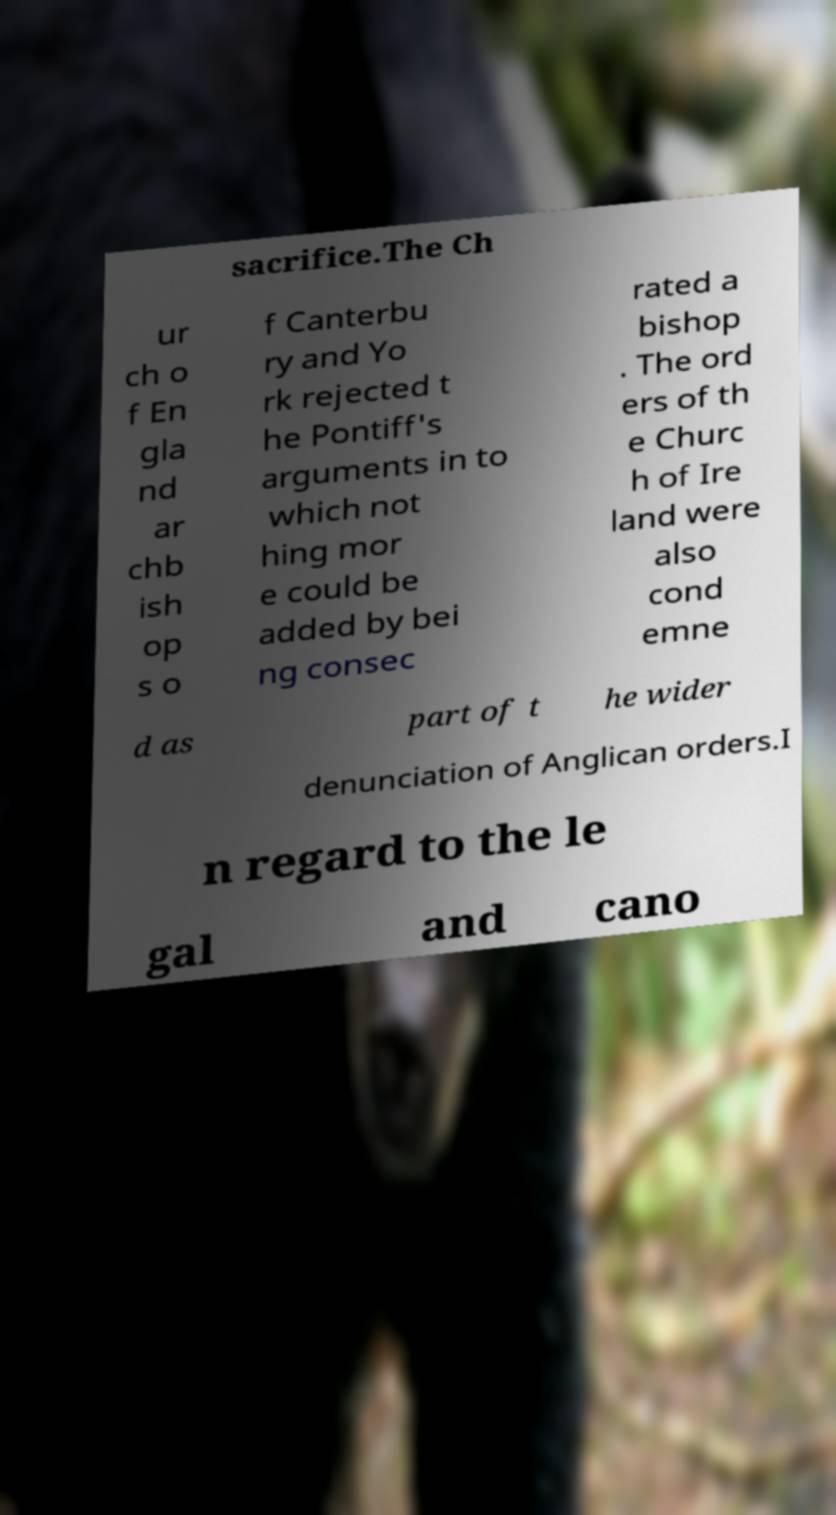Please identify and transcribe the text found in this image. sacrifice.The Ch ur ch o f En gla nd ar chb ish op s o f Canterbu ry and Yo rk rejected t he Pontiff's arguments in to which not hing mor e could be added by bei ng consec rated a bishop . The ord ers of th e Churc h of Ire land were also cond emne d as part of t he wider denunciation of Anglican orders.I n regard to the le gal and cano 